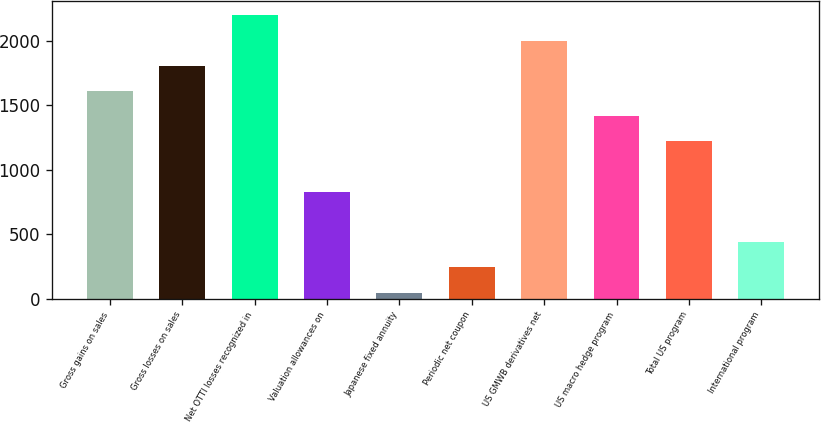Convert chart. <chart><loc_0><loc_0><loc_500><loc_500><bar_chart><fcel>Gross gains on sales<fcel>Gross losses on sales<fcel>Net OTTI losses recognized in<fcel>Valuation allowances on<fcel>Japanese fixed annuity<fcel>Periodic net coupon<fcel>US GMWB derivatives net<fcel>US macro hedge program<fcel>Total US program<fcel>International program<nl><fcel>1612.6<fcel>1808.3<fcel>2199.7<fcel>829.8<fcel>47<fcel>242.7<fcel>2004<fcel>1416.9<fcel>1221.2<fcel>438.4<nl></chart> 